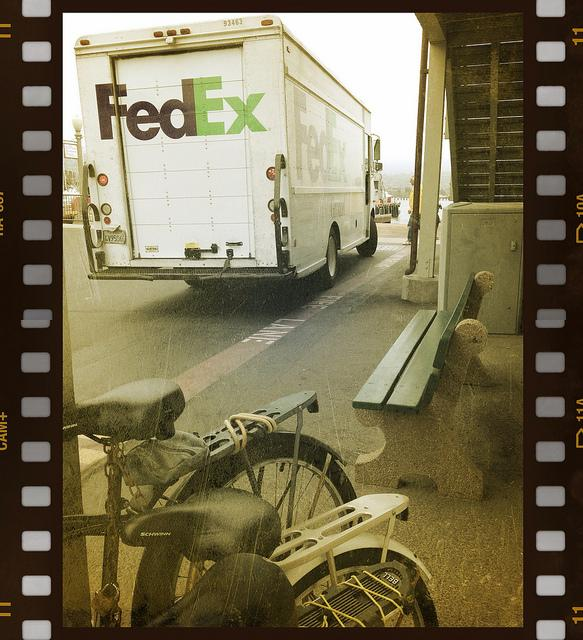What type of business is the truck for? delivery 